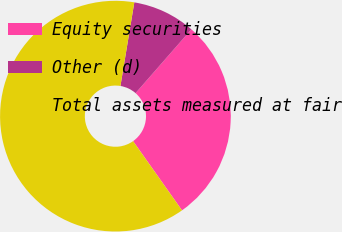Convert chart to OTSL. <chart><loc_0><loc_0><loc_500><loc_500><pie_chart><fcel>Equity securities<fcel>Other (d)<fcel>Total assets measured at fair<nl><fcel>28.77%<fcel>8.82%<fcel>62.41%<nl></chart> 